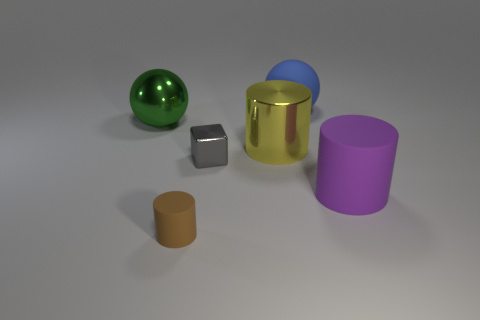Are there any other things that have the same shape as the gray metal object?
Your answer should be very brief. No. Are there more things that are in front of the big yellow shiny cylinder than tiny shiny blocks that are to the left of the gray metallic cube?
Your answer should be compact. Yes. There is a large ball right of the ball left of the small matte object; what is its color?
Ensure brevity in your answer.  Blue. What number of cubes are large purple matte objects or brown metallic things?
Your answer should be very brief. 0. How many big objects are both on the left side of the blue object and in front of the large green sphere?
Ensure brevity in your answer.  1. There is a big cylinder behind the metallic block; what color is it?
Offer a terse response. Yellow. What is the size of the ball that is the same material as the yellow object?
Your answer should be compact. Large. There is a cylinder that is behind the purple matte cylinder; how many large metallic objects are in front of it?
Your answer should be very brief. 0. There is a large blue matte object; how many matte cylinders are right of it?
Give a very brief answer. 1. What is the color of the large metallic thing to the right of the thing in front of the matte cylinder to the right of the blue sphere?
Provide a succinct answer. Yellow. 